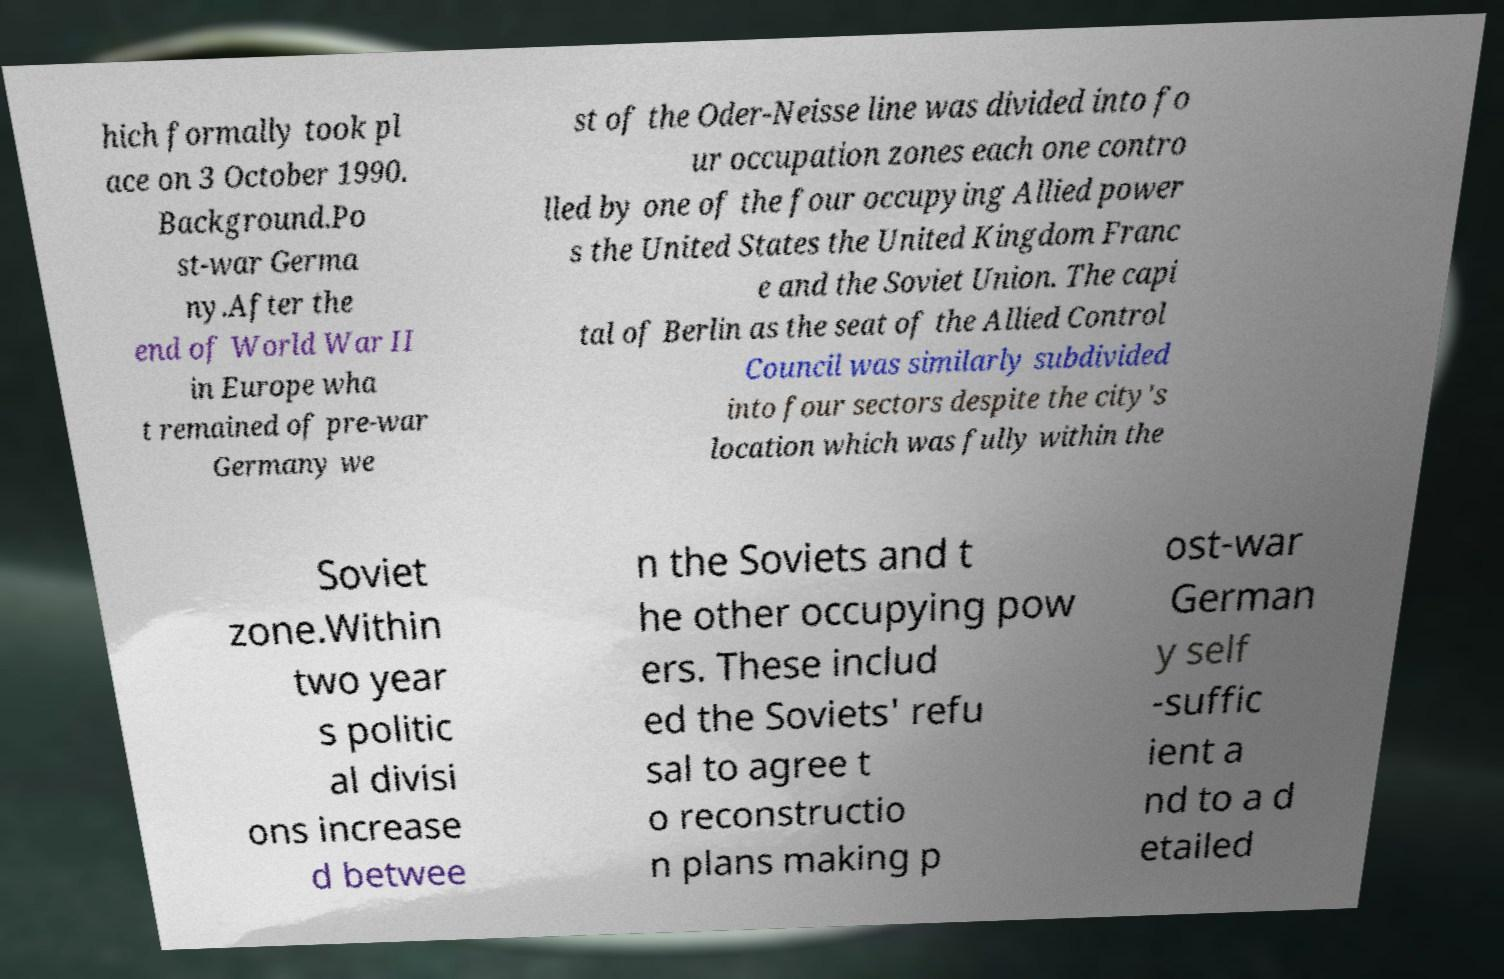Could you extract and type out the text from this image? hich formally took pl ace on 3 October 1990. Background.Po st-war Germa ny.After the end of World War II in Europe wha t remained of pre-war Germany we st of the Oder-Neisse line was divided into fo ur occupation zones each one contro lled by one of the four occupying Allied power s the United States the United Kingdom Franc e and the Soviet Union. The capi tal of Berlin as the seat of the Allied Control Council was similarly subdivided into four sectors despite the city's location which was fully within the Soviet zone.Within two year s politic al divisi ons increase d betwee n the Soviets and t he other occupying pow ers. These includ ed the Soviets' refu sal to agree t o reconstructio n plans making p ost-war German y self -suffic ient a nd to a d etailed 